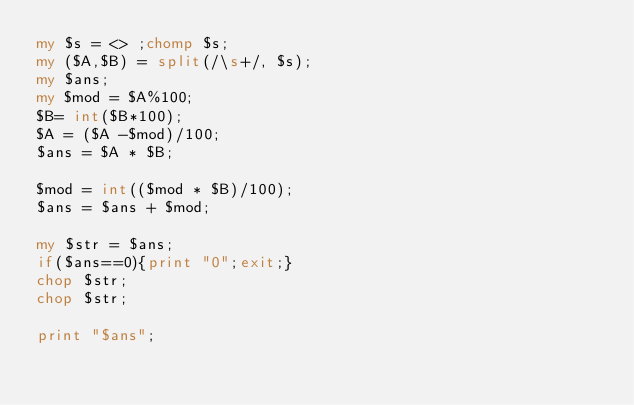<code> <loc_0><loc_0><loc_500><loc_500><_Perl_>my $s = <> ;chomp $s;
my ($A,$B) = split(/\s+/, $s);
my $ans;
my $mod = $A%100; 
$B= int($B*100);
$A = ($A -$mod)/100; 
$ans = $A * $B;

$mod = int(($mod * $B)/100);
$ans = $ans + $mod;

my $str = $ans;
if($ans==0){print "0";exit;}
chop $str;
chop $str;

print "$ans";</code> 